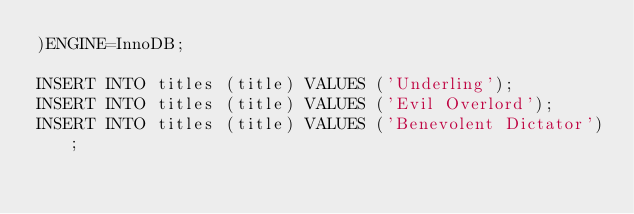Convert code to text. <code><loc_0><loc_0><loc_500><loc_500><_SQL_>)ENGINE=InnoDB;

INSERT INTO titles (title) VALUES ('Underling');
INSERT INTO titles (title) VALUES ('Evil Overlord');
INSERT INTO titles (title) VALUES ('Benevolent Dictator');</code> 